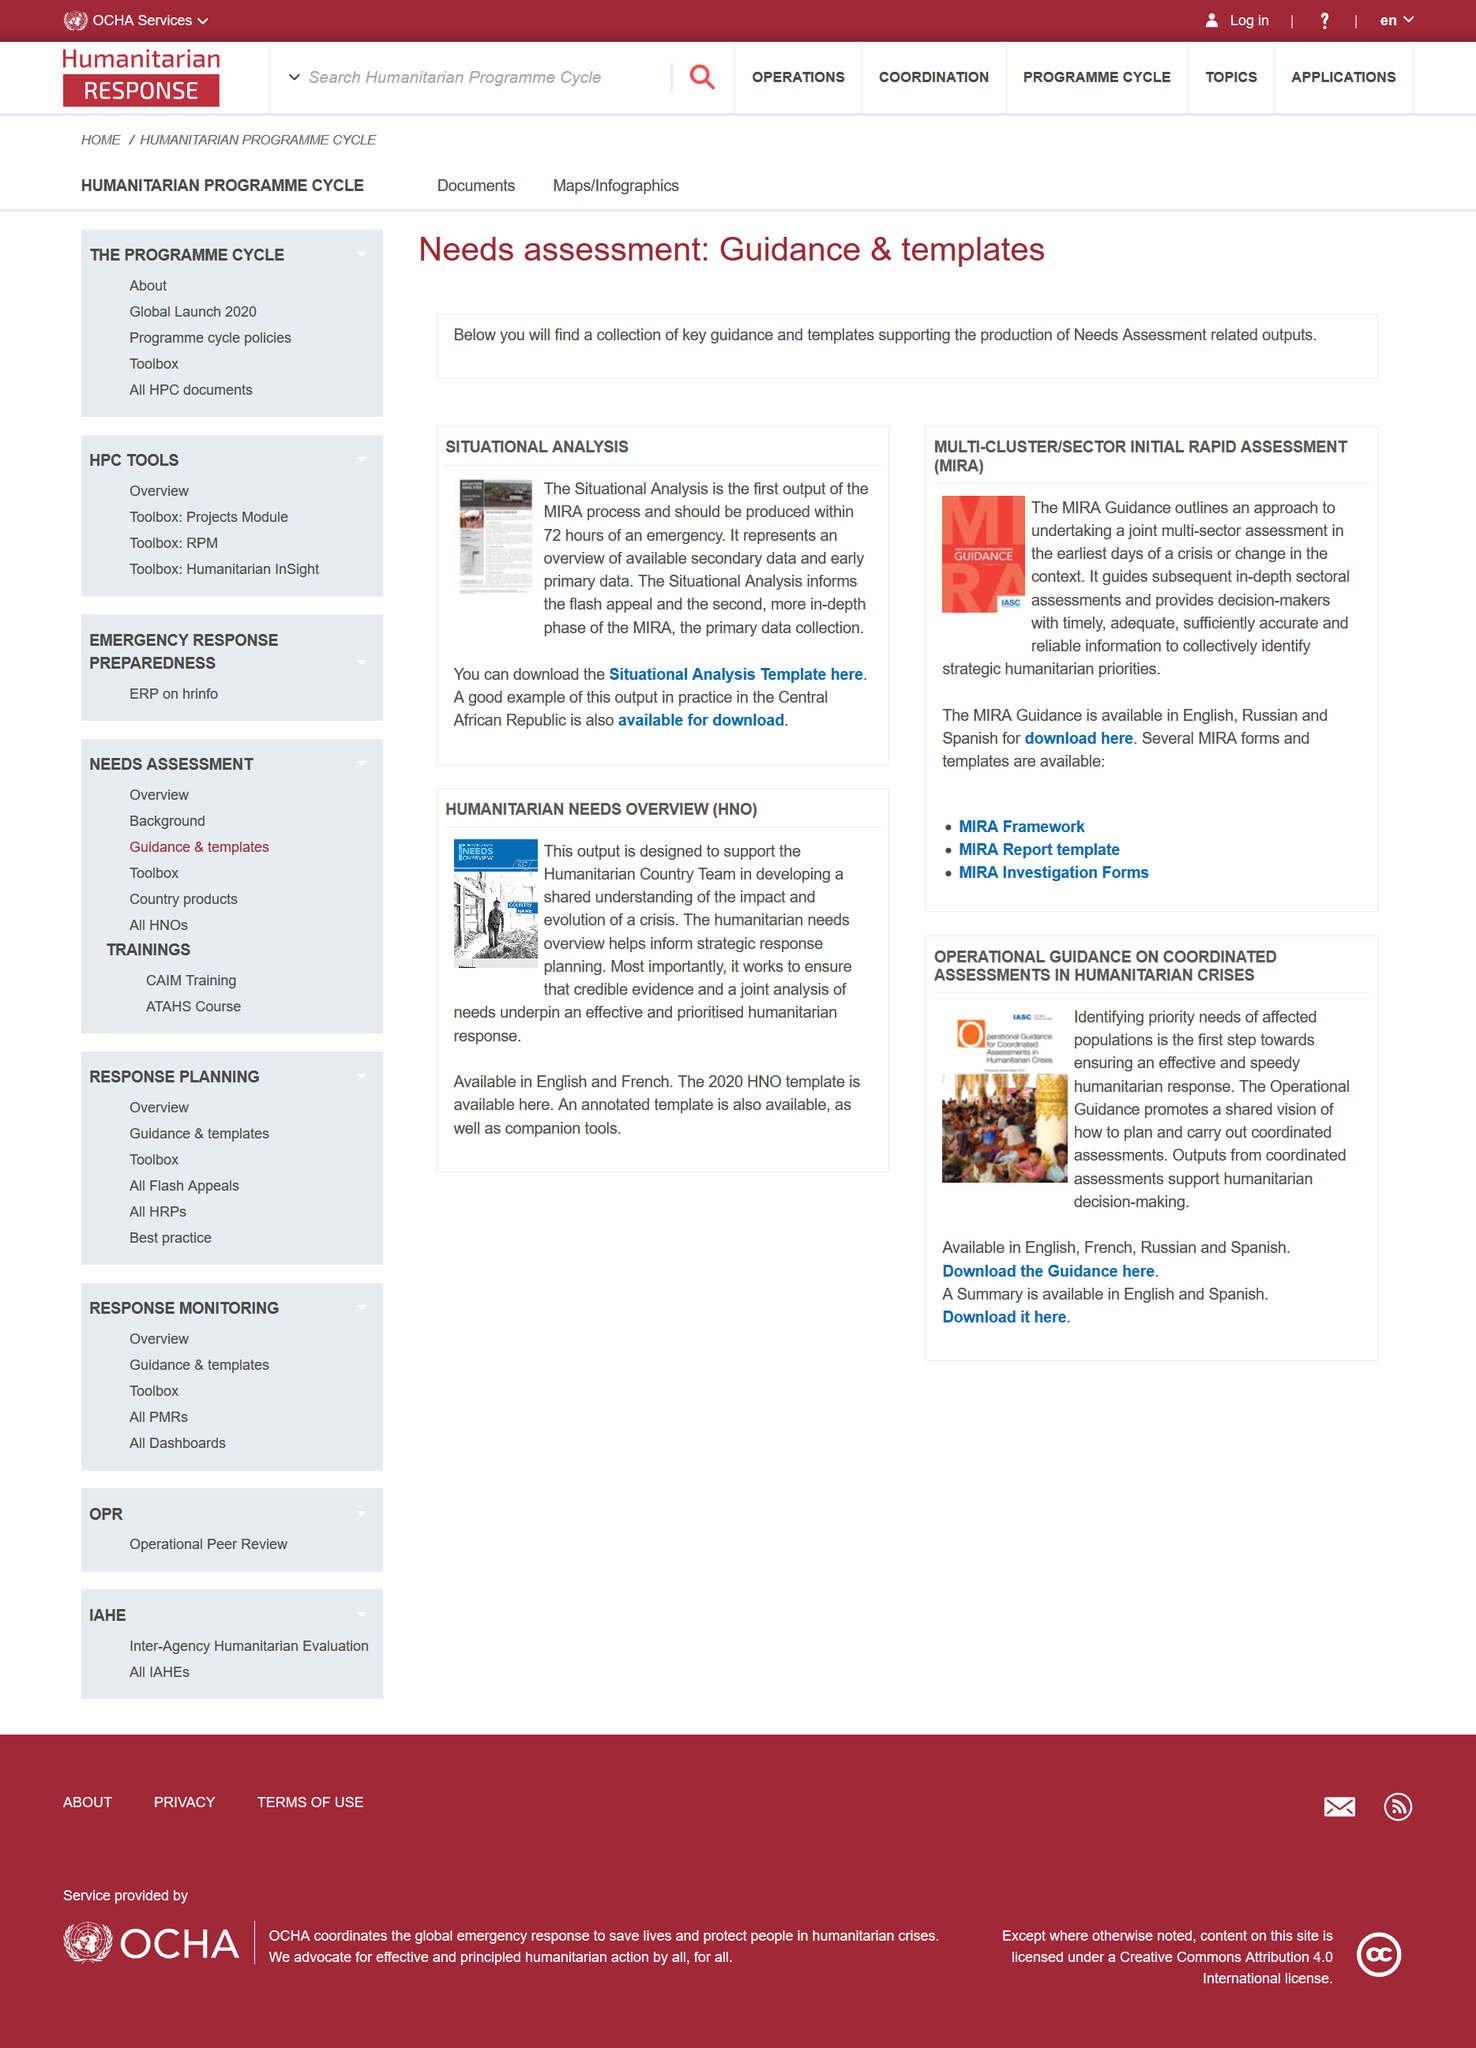Identify some key points in this picture. The outpost is vital in ensuring that credible evidence and a comprehensive analysis of needs are at the forefront of a successful and prioritized humanitarian response. Coordinated assessments produce vital outputs that support humanitarian decision-making by providing reliable and comprehensive information about the impact of disasters on affected communities and the resources needed to respond effectively. The Situational Analysis is available in both English and French languages. A good example of situational analysis in the workplace is the Central African Republic, where a comprehensive analysis was conducted to understand the unique challenges and opportunities facing the country's businesses and organizations. MIRA stands for Multi-Cluster/Sector Initial Rapid Assessment, which is a comprehensive assessment conducted to gather information on the current situation in a given area, taking into consideration various sectors and clusters, such as the social, economic, and security context. 